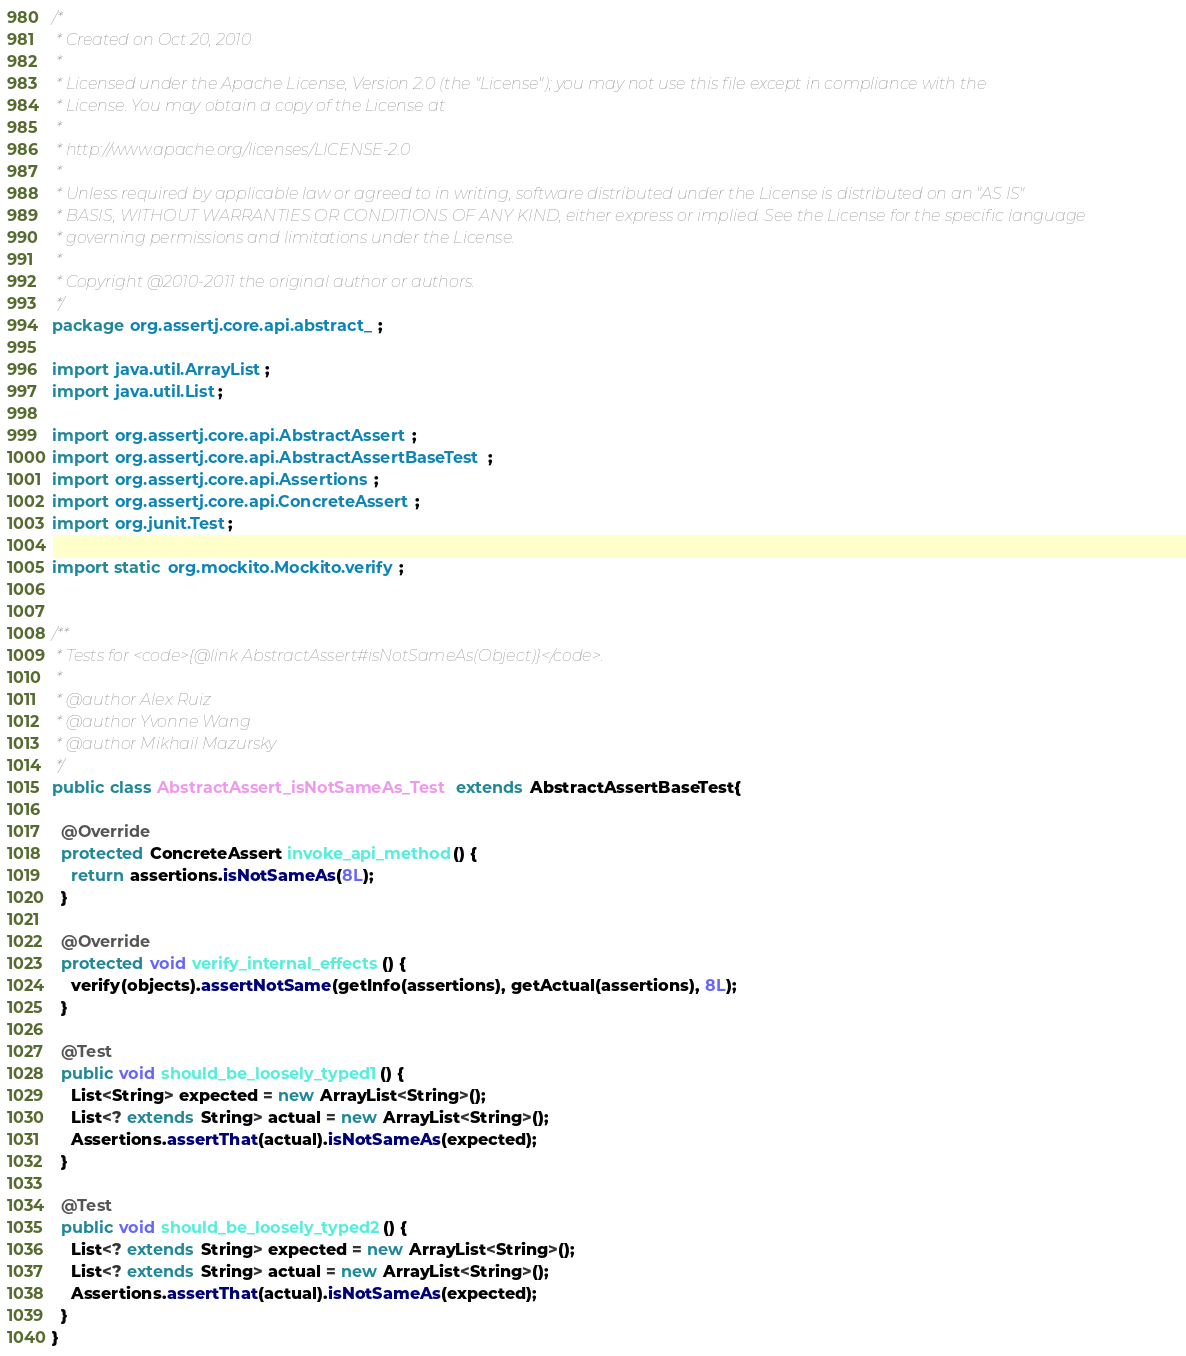<code> <loc_0><loc_0><loc_500><loc_500><_Java_>/*
 * Created on Oct 20, 2010
 * 
 * Licensed under the Apache License, Version 2.0 (the "License"); you may not use this file except in compliance with the
 * License. You may obtain a copy of the License at
 * 
 * http://www.apache.org/licenses/LICENSE-2.0
 * 
 * Unless required by applicable law or agreed to in writing, software distributed under the License is distributed on an "AS IS"
 * BASIS, WITHOUT WARRANTIES OR CONDITIONS OF ANY KIND, either express or implied. See the License for the specific language
 * governing permissions and limitations under the License.
 * 
 * Copyright @2010-2011 the original author or authors.
 */
package org.assertj.core.api.abstract_;

import java.util.ArrayList;
import java.util.List;

import org.assertj.core.api.AbstractAssert;
import org.assertj.core.api.AbstractAssertBaseTest;
import org.assertj.core.api.Assertions;
import org.assertj.core.api.ConcreteAssert;
import org.junit.Test;

import static org.mockito.Mockito.verify;


/**
 * Tests for <code>{@link AbstractAssert#isNotSameAs(Object)}</code>.
 * 
 * @author Alex Ruiz
 * @author Yvonne Wang
 * @author Mikhail Mazursky
 */
public class AbstractAssert_isNotSameAs_Test extends AbstractAssertBaseTest{

  @Override
  protected ConcreteAssert invoke_api_method() {
    return assertions.isNotSameAs(8L);
  }

  @Override
  protected void verify_internal_effects() {
    verify(objects).assertNotSame(getInfo(assertions), getActual(assertions), 8L);
  }

  @Test
  public void should_be_loosely_typed1() {
    List<String> expected = new ArrayList<String>();
    List<? extends String> actual = new ArrayList<String>();
    Assertions.assertThat(actual).isNotSameAs(expected);
  }

  @Test
  public void should_be_loosely_typed2() {
    List<? extends String> expected = new ArrayList<String>();
    List<? extends String> actual = new ArrayList<String>();
    Assertions.assertThat(actual).isNotSameAs(expected);
  }
}
</code> 